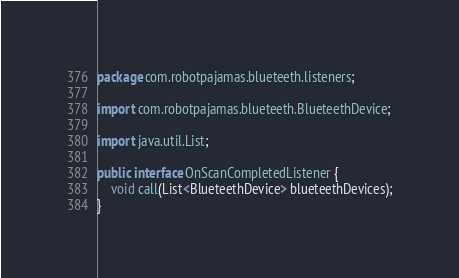<code> <loc_0><loc_0><loc_500><loc_500><_Java_>package com.robotpajamas.blueteeth.listeners;

import com.robotpajamas.blueteeth.BlueteethDevice;

import java.util.List;

public interface OnScanCompletedListener {
    void call(List<BlueteethDevice> blueteethDevices);
}
</code> 